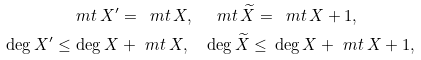<formula> <loc_0><loc_0><loc_500><loc_500>& \ m t \, X ^ { \prime } = \, \ m t \, X , \quad \ m t \, \widetilde { X } = \, \ m t \, X + 1 , \\ \deg X ^ { \prime } \leq & \, \deg X + \ m t \, X , \quad \deg \widetilde { X } \leq \, \deg X + \ m t \, X + 1 , \\</formula> 